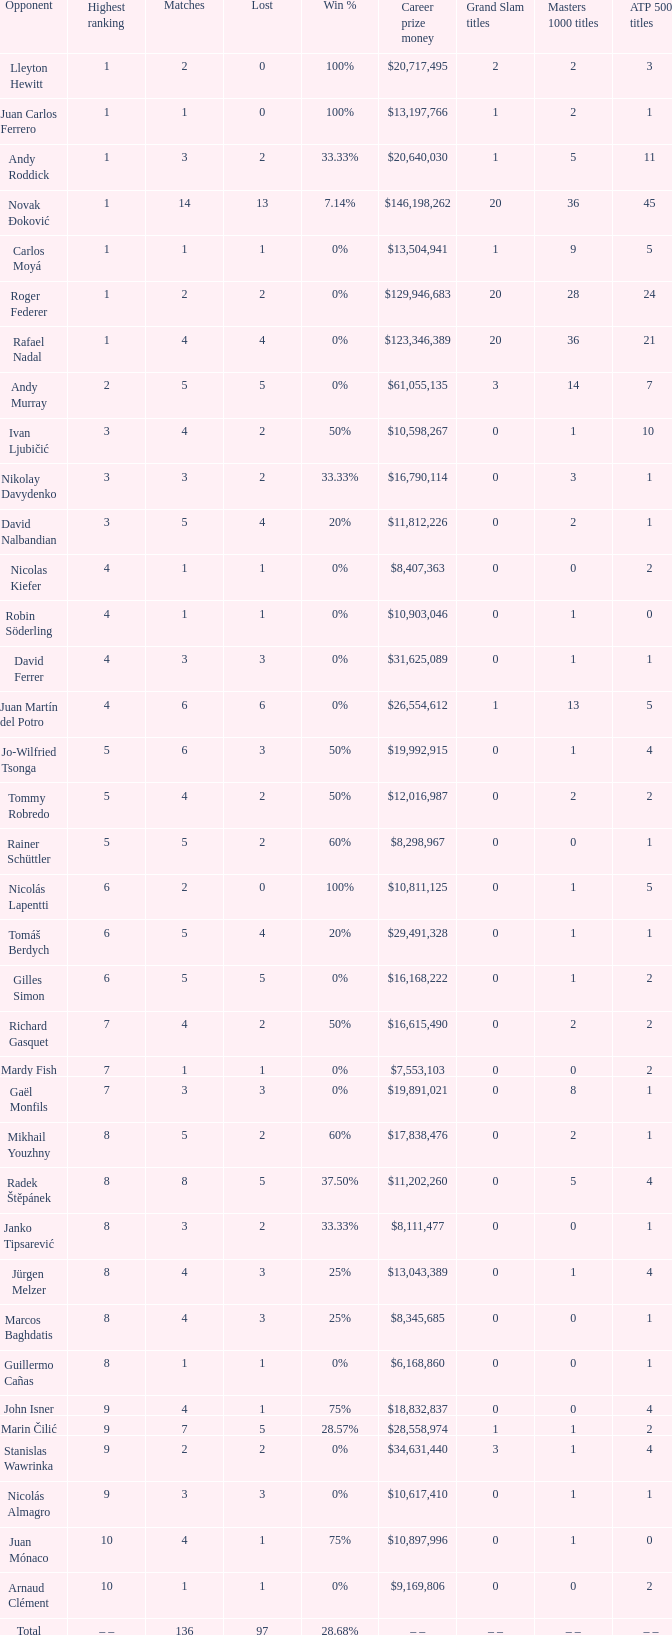What is the largest number Lost to david nalbandian with a Win Rate of 20%? 4.0. Would you mind parsing the complete table? {'header': ['Opponent', 'Highest ranking', 'Matches', 'Lost', 'Win %', 'Career prize money', 'Grand Slam titles', 'Masters 1000 titles', 'ATP 500 titles'], 'rows': [['Lleyton Hewitt', '1', '2', '0', '100%', '$20,717,495', '2', '2', '3 '], ['Juan Carlos Ferrero', '1', '1', '0', '100%', '$13,197,766', '1', '2', '1 '], ['Andy Roddick', '1', '3', '2', '33.33%', '$20,640,030', '1', '5', '11 '], ['Novak Đoković', '1', '14', '13', '7.14%', '$146,198,262', '20', '36', '45 '], ['Carlos Moyá', '1', '1', '1', '0%', '$13,504,941', '1', '9', '5 '], ['Roger Federer', '1', '2', '2', '0%', '$129,946,683', '20', '28', '24 '], ['Rafael Nadal', '1', '4', '4', '0%', '$123,346,389', '20', '36', '21 '], ['Andy Murray', '2', '5', '5', '0%', '$61,055,135', '3', '14', '7 '], ['Ivan Ljubičić', '3', '4', '2', '50%', '$10,598,267', '0', '1', '10  '], ['Nikolay Davydenko', '3', '3', '2', '33.33%', '$16,790,114', '0', '3', '1 '], ['David Nalbandian', '3', '5', '4', '20%', '$11,812,226', '0', '2', '1 '], ['Nicolas Kiefer', '4', '1', '1', '0%', '$8,407,363', '0', '0', '2 '], ['Robin Söderling', '4', '1', '1', '0%', '$10,903,046', '0', '1', '0 '], ['David Ferrer', '4', '3', '3', '0%', '$31,625,089', '0', '1', '1 '], ['Juan Martín del Potro', '4', '6', '6', '0%', '$26,554,612', '1', '13', '5 '], ['Jo-Wilfried Tsonga', '5', '6', '3', '50%', '$19,992,915', '0', '1', '4 '], ['Tommy Robredo', '5', '4', '2', '50%', '$12,016,987', '0', '2', '2 '], ['Rainer Schüttler', '5', '5', '2', '60%', '$8,298,967', '0', '0', '1 '], ['Nicolás Lapentti', '6', '2', '0', '100%', '$10,811,125', '0', '1', '5 '], ['Tomáš Berdych', '6', '5', '4', '20%', '$29,491,328', '0', '1', '1 '], ['Gilles Simon', '6', '5', '5', '0%', '$16,168,222', '0', '1', '2 '], ['Richard Gasquet', '7', '4', '2', '50%', '$16,615,490', '0', '2', '2 '], ['Mardy Fish', '7', '1', '1', '0%', '$7,553,103', '0', '0', '2 '], ['Gaël Monfils', '7', '3', '3', '0%', '$19,891,021', '0', '8', '1 '], ['Mikhail Youzhny', '8', '5', '2', '60%', '$17,838,476', '0', '2', '1 '], ['Radek Štěpánek', '8', '8', '5', '37.50%', '$11,202,260', '0', '5', '4 '], ['Janko Tipsarević', '8', '3', '2', '33.33%', '$8,111,477', '0', '0', '1 '], ['Jürgen Melzer', '8', '4', '3', '25%', '$13,043,389', '0', '1', '4 '], ['Marcos Baghdatis', '8', '4', '3', '25%', '$8,345,685', '0', '0', '1 '], ['Guillermo Cañas', '8', '1', '1', '0%', '$6,168,860', '0', '0', '1 '], ['John Isner', '9', '4', '1', '75%', '$18,832,837', '0', '0', '4 '], ['Marin Čilić', '9', '7', '5', '28.57%', '$28,558,974', '1', '1', '2 '], ['Stanislas Wawrinka', '9', '2', '2', '0%', '$34,631,440', '3', '1', '4 '], ['Nicolás Almagro', '9', '3', '3', '0%', '$10,617,410', '0', '1', '1 '], ['Juan Mónaco', '10', '4', '1', '75%', '$10,897,996', '0', '1', '0 '], ['Arnaud Clément', '10', '1', '1', '0%', '$9,169,806', '0', '0', '2 '], ['Total', '– –', '136', '97', '28.68%', '– –', '– –', '– –', '– –']]} 